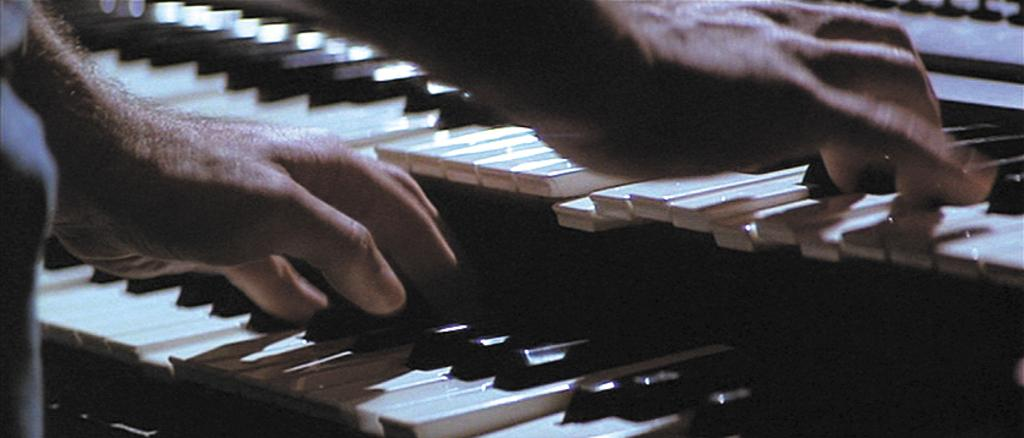What is the main subject of the image? The main subject of the image is a man. What is the man doing in the image? The man is standing and playing a guitar. What type of letters is the man wearing on his fingers while playing the guitar? There are no letters visible on the man's fingers in the image. What committee is the man a part of while playing the guitar? There is no information about any committee in the image; it only shows a man playing a guitar. 